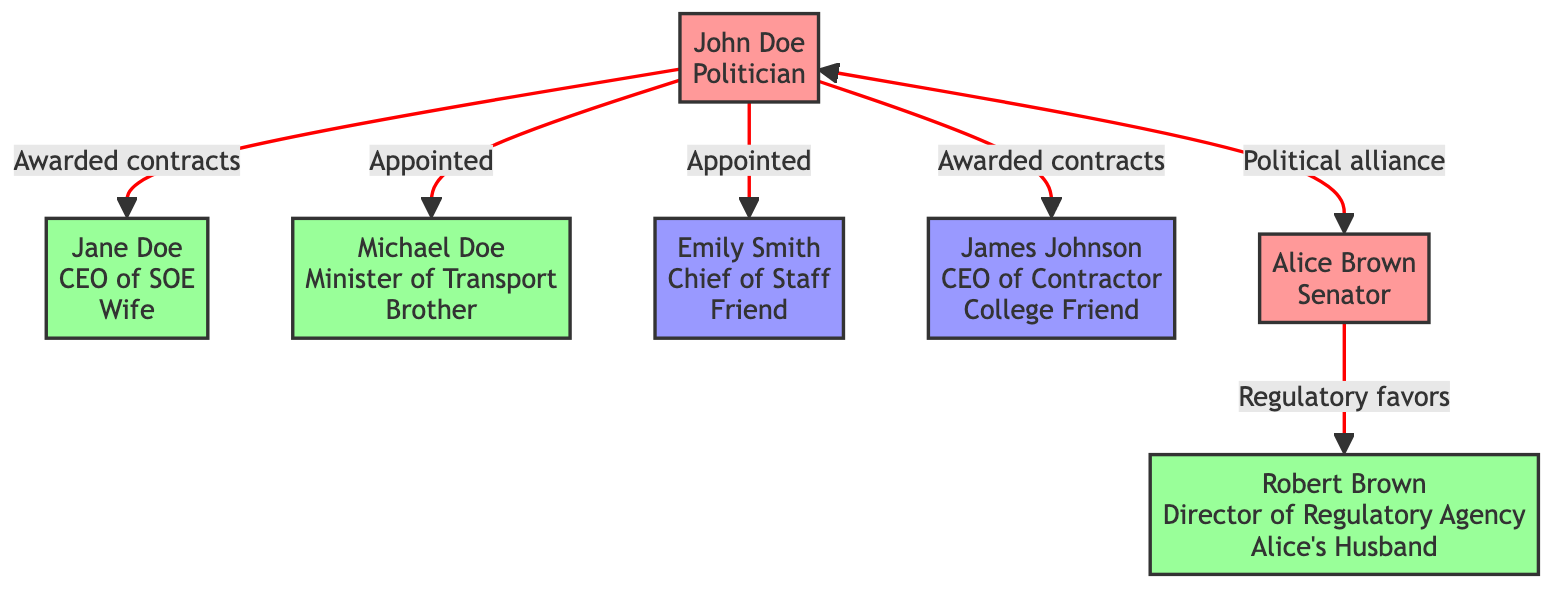What's the number of politicians in the diagram? There are two politicians identified as John Doe and Alice Brown in the network diagram.
Answer: 2 Which family member is a CEO of a State-Owned Enterprise? Jane Doe, identified as the wife of John Doe, is labeled as the CEO of a State-Owned Enterprise in the diagram.
Answer: Jane Doe How many instances of favoritism are depicted in the diagram? The diagram shows two instances of favoritism: one awarded to John Doe's wife and the other awarded to his college friend.
Answer: 2 What is the relationship type between John Doe and his brother Michael Doe? The diagram indicates the relationship type between them as 'appointment', specifically showing that John Doe appointed Michael Doe as the Minister of Transport.
Answer: appointment What role does Robert Brown have in connection with Alice Brown? Robert Brown is described as the Director of a Regulatory Agency and is noted as the husband of Alice Brown in the diagram.
Answer: Director of Regulatory Agency Which two individuals share a political alliance? John Doe and Alice Brown share a political alliance as indicated by the two-way connection showing 'mutual support and cover-ups'.
Answer: John Doe and Alice Brown In what capacity did John Doe appoint Emily Smith? John Doe appointed Emily Smith as his Chief of Staff, as explicitly stated in the description within the diagram.
Answer: Chief of Staff How does Alice Brown's relationship with Robert Brown indicate a potential conflict of interest? Alice Brown's regulatory decisions favor her husband's business interests, which suggests a conflict of interest as it directly involves personal ties affecting professional judgment.
Answer: conflict of interest What type of relationship exists between James Johnson and John Doe? The relationship type is labeled as favoritism, as John Doe awarded public contracts to James Johnson's company.
Answer: favoritism 